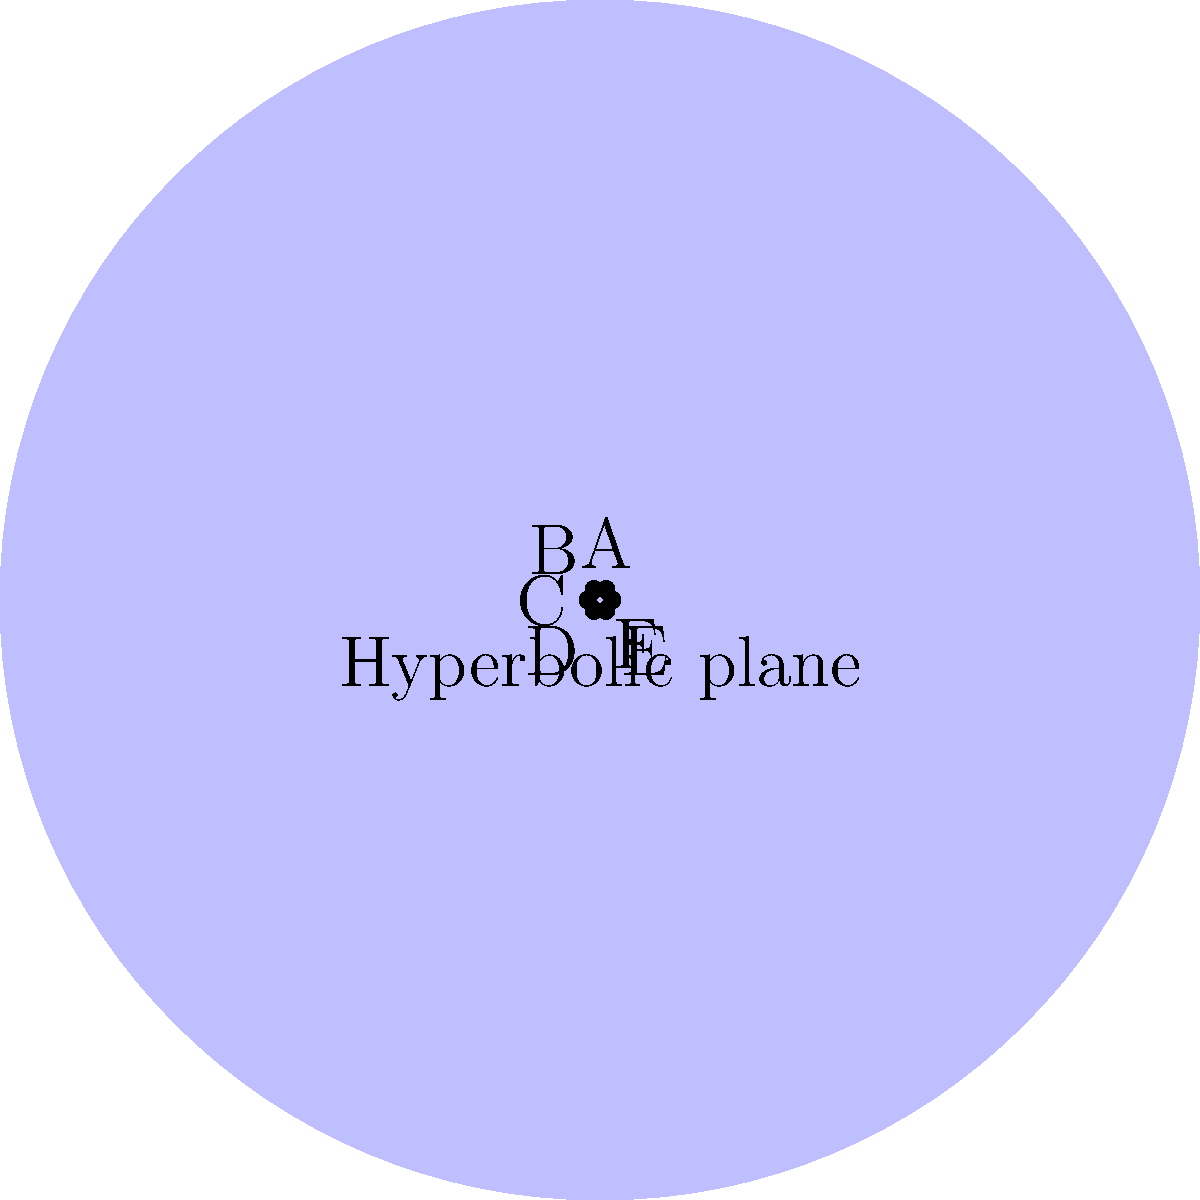In a hyperbolic plane, as shown in the figure, consider a regular hexagon ABCDEF. If the sum of the interior angles of this hexagon is $6\theta$, what is the value of $\theta$ in radians? (Note: In hyperbolic geometry, the sum of interior angles of a polygon is less than the Euclidean case.) To solve this problem, let's follow these steps:

1) In Euclidean geometry, the sum of interior angles of a hexagon is $(n-2) \times 180°$, where $n$ is the number of sides. For a hexagon, this would be $720°$ or $4\pi$ radians.

2) In hyperbolic geometry, the sum of interior angles of a polygon is always less than the Euclidean case. The difference is called the defect.

3) The sum of angles in our hyperbolic hexagon is given as $6\theta$. We need to find $\theta$.

4) In hyperbolic geometry, for a hexagon, the following formula holds:

   $\text{Area of hexagon} = 6\theta - 4\pi$

5) The area of a hyperbolic polygon is always positive. Therefore:

   $6\theta - 4\pi > 0$

6) Solving this inequality:
   
   $6\theta > 4\pi$
   $\theta > \frac{2\pi}{3}$

7) Since we're asked for the exact value of $\theta$, and not an inequality, we can conclude that $\theta$ must be equal to $\frac{2\pi}{3}$.

8) We can verify: $6 \times \frac{2\pi}{3} = 4\pi$, which is indeed less than the Euclidean case of $720°$ or $4\pi$ radians.
Answer: $\frac{2\pi}{3}$ radians 